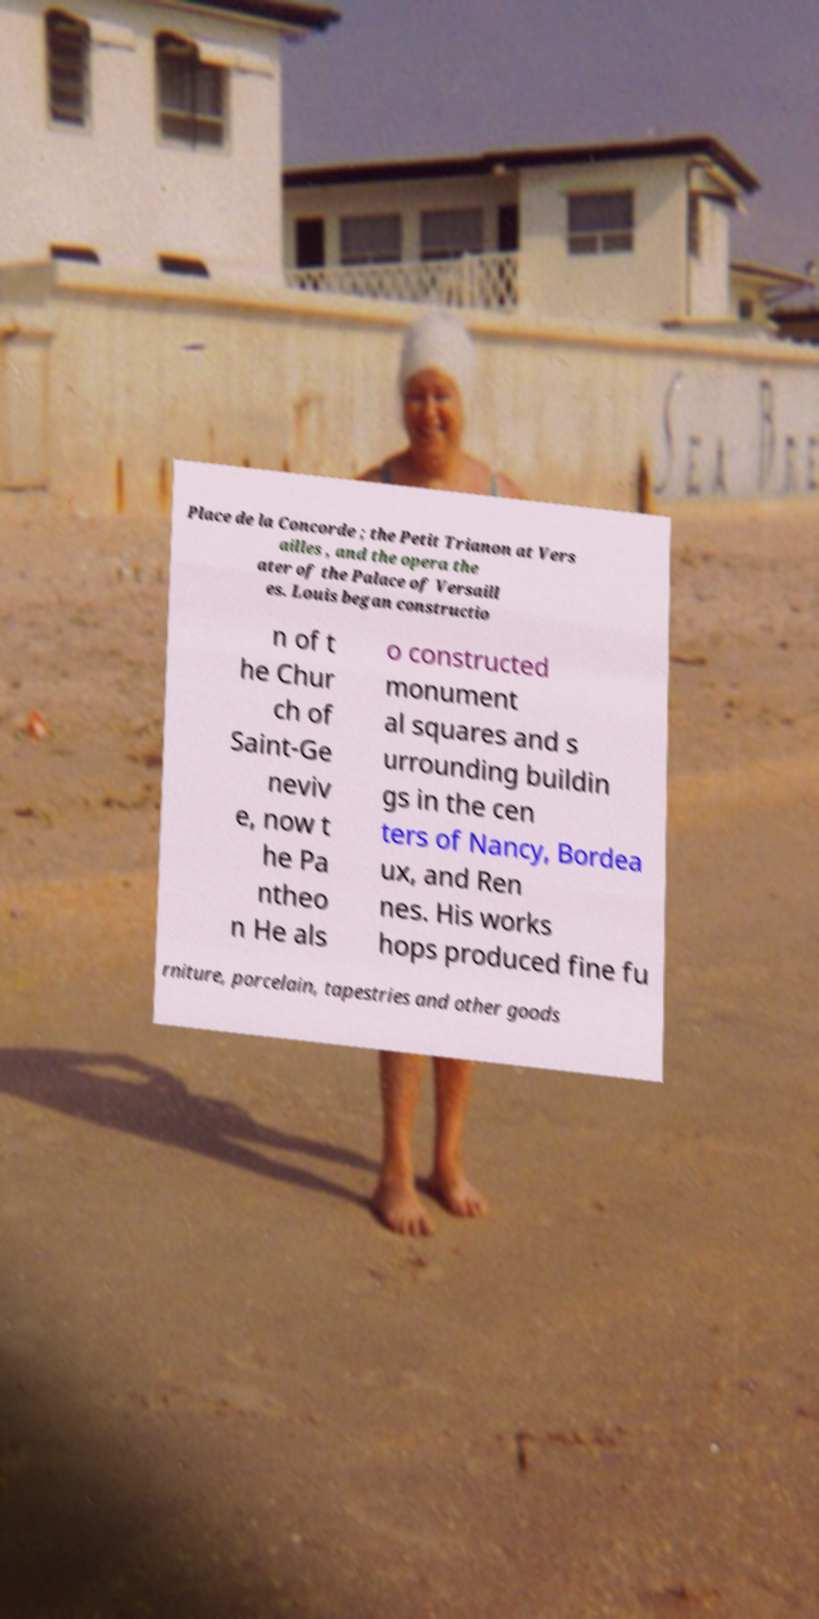Can you read and provide the text displayed in the image?This photo seems to have some interesting text. Can you extract and type it out for me? Place de la Concorde ; the Petit Trianon at Vers ailles , and the opera the ater of the Palace of Versaill es. Louis began constructio n of t he Chur ch of Saint-Ge neviv e, now t he Pa ntheo n He als o constructed monument al squares and s urrounding buildin gs in the cen ters of Nancy, Bordea ux, and Ren nes. His works hops produced fine fu rniture, porcelain, tapestries and other goods 